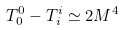<formula> <loc_0><loc_0><loc_500><loc_500>T ^ { 0 } _ { 0 } - T ^ { i } _ { i } \simeq 2 M ^ { 4 }</formula> 